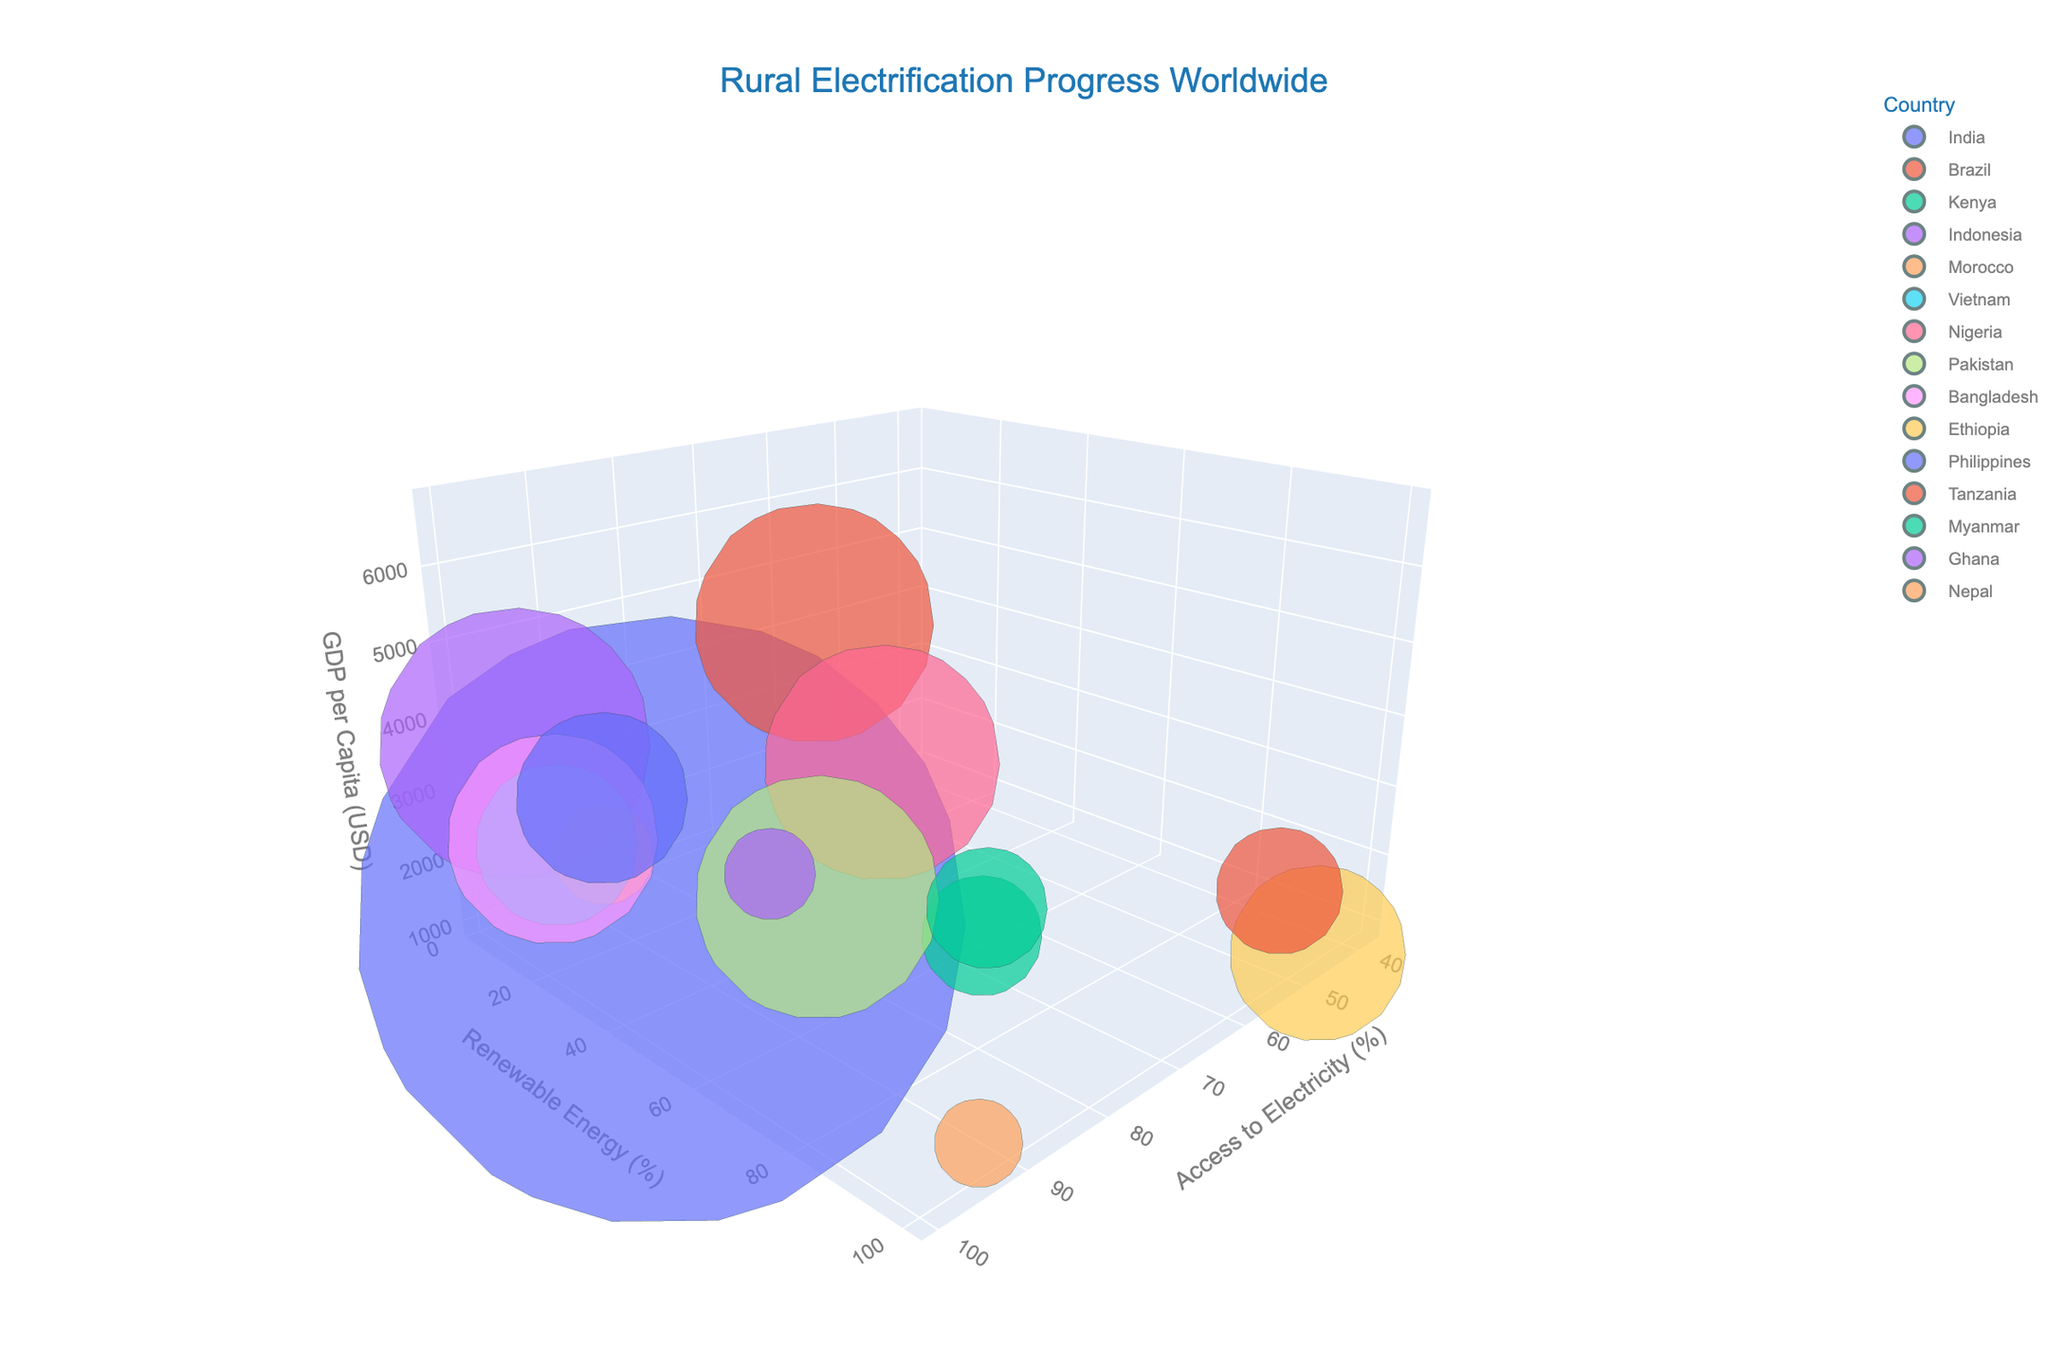What is the title of the figure? The title of the figure is located at the top and usually provides an overview of what the figure represents. In this case, it is clearly stated in the center of the figure.
Answer: Rural Electrification Progress Worldwide What are the three main variables plotted in this 3D bubble chart? To determine the three main variables, we need to look at the axes labels. The x-axis, y-axis, and z-axis all represent a different variable.
Answer: Access to Electricity (%), Renewable Energy (%), GDP per Capita (USD) Which country has the highest percentage of renewable energy? Look for the highest position on the Renewable Energy (%) axis. Hover over the data points to see which country is associated with this value.
Answer: Ethiopia Which country has the highest GDP per capita? Focus on the GDP per Capita (USD) axis and identify the country positioned at the highest value on this axis. Hovering over data points helps.
Answer: Brazil Between Kenya and Nepal, which country has a higher percentage of renewable energy usage? Locate the data points for Kenya and Nepal. Then compare their positions along the Renewable Energy (%) axis.
Answer: Nepal Which country has the largest bubble size and what does this represent? Identify the country with the largest bubble size on the chart. The bubble size represents population, as per the description given.
Answer: India What trend can be observed between Access to Electricity and GDP per Capita from the chart? By examining the general distribution of data points across the X and Z axes, determine whether there is a visible trend between higher access to electricity and higher GDP per capita.
Answer: Generally, countries with higher access to electricity tend to have higher GDP per capita 